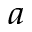Convert formula to latex. <formula><loc_0><loc_0><loc_500><loc_500>^ { a }</formula> 